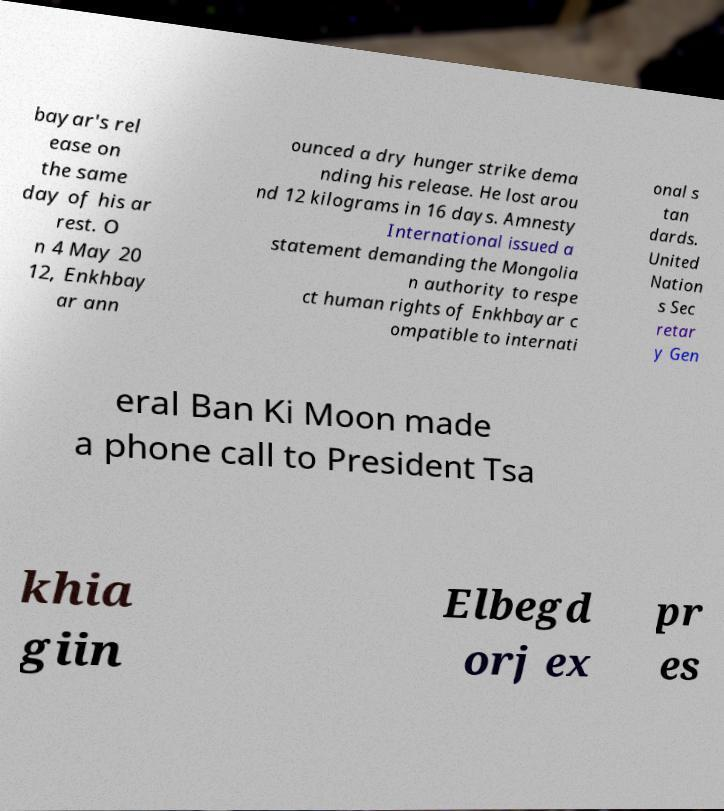For documentation purposes, I need the text within this image transcribed. Could you provide that? bayar's rel ease on the same day of his ar rest. O n 4 May 20 12, Enkhbay ar ann ounced a dry hunger strike dema nding his release. He lost arou nd 12 kilograms in 16 days. Amnesty International issued a statement demanding the Mongolia n authority to respe ct human rights of Enkhbayar c ompatible to internati onal s tan dards. United Nation s Sec retar y Gen eral Ban Ki Moon made a phone call to President Tsa khia giin Elbegd orj ex pr es 